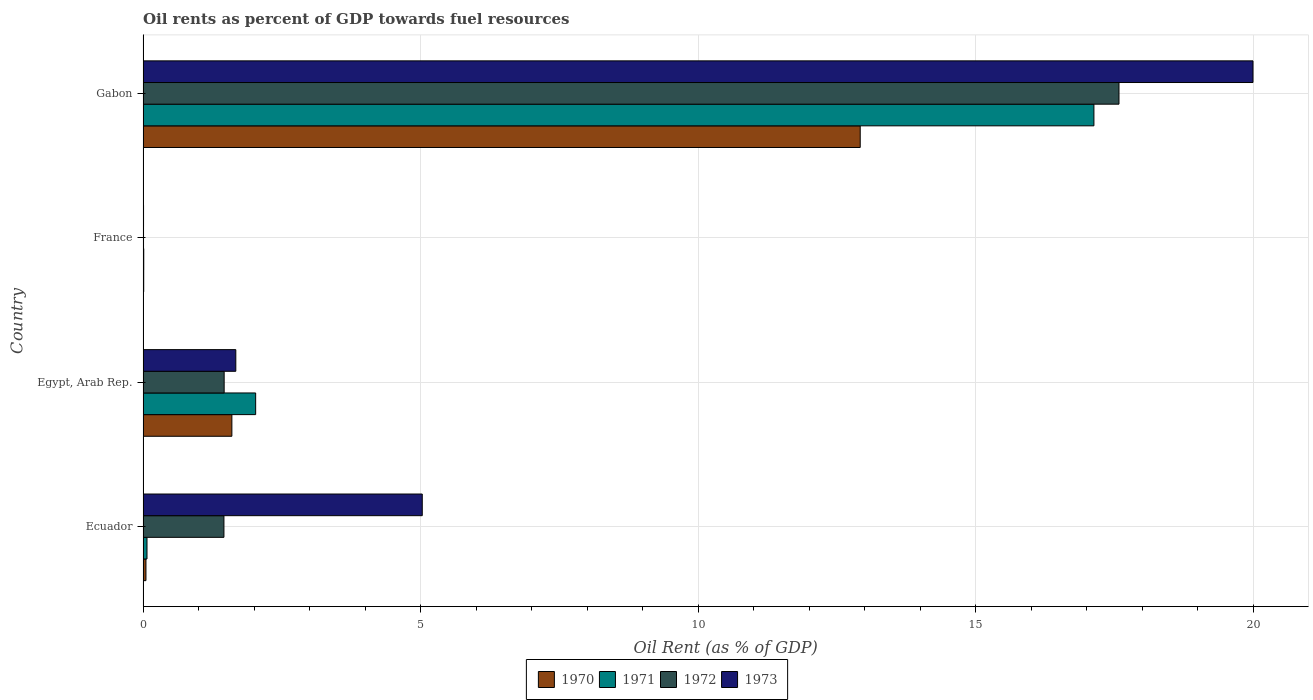How many different coloured bars are there?
Offer a terse response. 4. Are the number of bars per tick equal to the number of legend labels?
Offer a very short reply. Yes. Are the number of bars on each tick of the Y-axis equal?
Your response must be concise. Yes. How many bars are there on the 4th tick from the bottom?
Offer a very short reply. 4. What is the label of the 3rd group of bars from the top?
Keep it short and to the point. Egypt, Arab Rep. In how many cases, is the number of bars for a given country not equal to the number of legend labels?
Give a very brief answer. 0. What is the oil rent in 1973 in Ecuador?
Provide a short and direct response. 5.03. Across all countries, what is the maximum oil rent in 1971?
Offer a terse response. 17.13. Across all countries, what is the minimum oil rent in 1972?
Offer a very short reply. 0.01. In which country was the oil rent in 1973 maximum?
Offer a very short reply. Gabon. What is the total oil rent in 1973 in the graph?
Ensure brevity in your answer.  26.7. What is the difference between the oil rent in 1972 in Egypt, Arab Rep. and that in Gabon?
Provide a succinct answer. -16.12. What is the difference between the oil rent in 1971 in Egypt, Arab Rep. and the oil rent in 1972 in Gabon?
Offer a very short reply. -15.55. What is the average oil rent in 1970 per country?
Make the answer very short. 3.65. What is the difference between the oil rent in 1971 and oil rent in 1972 in Gabon?
Ensure brevity in your answer.  -0.45. What is the ratio of the oil rent in 1972 in France to that in Gabon?
Offer a very short reply. 0. Is the oil rent in 1972 in France less than that in Gabon?
Ensure brevity in your answer.  Yes. Is the difference between the oil rent in 1971 in Ecuador and Gabon greater than the difference between the oil rent in 1972 in Ecuador and Gabon?
Your answer should be very brief. No. What is the difference between the highest and the second highest oil rent in 1972?
Your response must be concise. 16.12. What is the difference between the highest and the lowest oil rent in 1970?
Make the answer very short. 12.91. In how many countries, is the oil rent in 1970 greater than the average oil rent in 1970 taken over all countries?
Offer a terse response. 1. Is the sum of the oil rent in 1971 in Ecuador and Egypt, Arab Rep. greater than the maximum oil rent in 1972 across all countries?
Provide a short and direct response. No. What does the 3rd bar from the bottom in Egypt, Arab Rep. represents?
Keep it short and to the point. 1972. Does the graph contain any zero values?
Give a very brief answer. No. What is the title of the graph?
Provide a succinct answer. Oil rents as percent of GDP towards fuel resources. What is the label or title of the X-axis?
Offer a terse response. Oil Rent (as % of GDP). What is the label or title of the Y-axis?
Keep it short and to the point. Country. What is the Oil Rent (as % of GDP) of 1970 in Ecuador?
Give a very brief answer. 0.05. What is the Oil Rent (as % of GDP) in 1971 in Ecuador?
Offer a very short reply. 0.07. What is the Oil Rent (as % of GDP) of 1972 in Ecuador?
Your answer should be compact. 1.46. What is the Oil Rent (as % of GDP) of 1973 in Ecuador?
Your answer should be very brief. 5.03. What is the Oil Rent (as % of GDP) in 1970 in Egypt, Arab Rep.?
Make the answer very short. 1.6. What is the Oil Rent (as % of GDP) of 1971 in Egypt, Arab Rep.?
Keep it short and to the point. 2.03. What is the Oil Rent (as % of GDP) in 1972 in Egypt, Arab Rep.?
Give a very brief answer. 1.46. What is the Oil Rent (as % of GDP) in 1973 in Egypt, Arab Rep.?
Give a very brief answer. 1.67. What is the Oil Rent (as % of GDP) in 1970 in France?
Keep it short and to the point. 0.01. What is the Oil Rent (as % of GDP) in 1971 in France?
Make the answer very short. 0.01. What is the Oil Rent (as % of GDP) of 1972 in France?
Offer a very short reply. 0.01. What is the Oil Rent (as % of GDP) in 1973 in France?
Your answer should be compact. 0.01. What is the Oil Rent (as % of GDP) in 1970 in Gabon?
Ensure brevity in your answer.  12.92. What is the Oil Rent (as % of GDP) of 1971 in Gabon?
Offer a terse response. 17.13. What is the Oil Rent (as % of GDP) of 1972 in Gabon?
Provide a succinct answer. 17.58. What is the Oil Rent (as % of GDP) in 1973 in Gabon?
Offer a very short reply. 19.99. Across all countries, what is the maximum Oil Rent (as % of GDP) of 1970?
Provide a short and direct response. 12.92. Across all countries, what is the maximum Oil Rent (as % of GDP) of 1971?
Give a very brief answer. 17.13. Across all countries, what is the maximum Oil Rent (as % of GDP) of 1972?
Your answer should be compact. 17.58. Across all countries, what is the maximum Oil Rent (as % of GDP) of 1973?
Ensure brevity in your answer.  19.99. Across all countries, what is the minimum Oil Rent (as % of GDP) in 1970?
Your answer should be compact. 0.01. Across all countries, what is the minimum Oil Rent (as % of GDP) in 1971?
Give a very brief answer. 0.01. Across all countries, what is the minimum Oil Rent (as % of GDP) of 1972?
Provide a short and direct response. 0.01. Across all countries, what is the minimum Oil Rent (as % of GDP) of 1973?
Keep it short and to the point. 0.01. What is the total Oil Rent (as % of GDP) of 1970 in the graph?
Make the answer very short. 14.58. What is the total Oil Rent (as % of GDP) of 1971 in the graph?
Your answer should be very brief. 19.24. What is the total Oil Rent (as % of GDP) in 1972 in the graph?
Your answer should be very brief. 20.51. What is the total Oil Rent (as % of GDP) of 1973 in the graph?
Make the answer very short. 26.7. What is the difference between the Oil Rent (as % of GDP) in 1970 in Ecuador and that in Egypt, Arab Rep.?
Your answer should be compact. -1.55. What is the difference between the Oil Rent (as % of GDP) of 1971 in Ecuador and that in Egypt, Arab Rep.?
Keep it short and to the point. -1.96. What is the difference between the Oil Rent (as % of GDP) of 1972 in Ecuador and that in Egypt, Arab Rep.?
Keep it short and to the point. -0. What is the difference between the Oil Rent (as % of GDP) in 1973 in Ecuador and that in Egypt, Arab Rep.?
Ensure brevity in your answer.  3.36. What is the difference between the Oil Rent (as % of GDP) of 1970 in Ecuador and that in France?
Provide a succinct answer. 0.04. What is the difference between the Oil Rent (as % of GDP) in 1971 in Ecuador and that in France?
Provide a succinct answer. 0.06. What is the difference between the Oil Rent (as % of GDP) in 1972 in Ecuador and that in France?
Provide a short and direct response. 1.45. What is the difference between the Oil Rent (as % of GDP) in 1973 in Ecuador and that in France?
Make the answer very short. 5.02. What is the difference between the Oil Rent (as % of GDP) of 1970 in Ecuador and that in Gabon?
Your answer should be compact. -12.87. What is the difference between the Oil Rent (as % of GDP) of 1971 in Ecuador and that in Gabon?
Provide a succinct answer. -17.06. What is the difference between the Oil Rent (as % of GDP) in 1972 in Ecuador and that in Gabon?
Offer a terse response. -16.12. What is the difference between the Oil Rent (as % of GDP) in 1973 in Ecuador and that in Gabon?
Ensure brevity in your answer.  -14.96. What is the difference between the Oil Rent (as % of GDP) in 1970 in Egypt, Arab Rep. and that in France?
Your response must be concise. 1.59. What is the difference between the Oil Rent (as % of GDP) of 1971 in Egypt, Arab Rep. and that in France?
Offer a terse response. 2.02. What is the difference between the Oil Rent (as % of GDP) of 1972 in Egypt, Arab Rep. and that in France?
Give a very brief answer. 1.45. What is the difference between the Oil Rent (as % of GDP) in 1973 in Egypt, Arab Rep. and that in France?
Your answer should be very brief. 1.66. What is the difference between the Oil Rent (as % of GDP) of 1970 in Egypt, Arab Rep. and that in Gabon?
Ensure brevity in your answer.  -11.32. What is the difference between the Oil Rent (as % of GDP) in 1971 in Egypt, Arab Rep. and that in Gabon?
Give a very brief answer. -15.1. What is the difference between the Oil Rent (as % of GDP) of 1972 in Egypt, Arab Rep. and that in Gabon?
Your answer should be compact. -16.12. What is the difference between the Oil Rent (as % of GDP) of 1973 in Egypt, Arab Rep. and that in Gabon?
Make the answer very short. -18.32. What is the difference between the Oil Rent (as % of GDP) in 1970 in France and that in Gabon?
Keep it short and to the point. -12.91. What is the difference between the Oil Rent (as % of GDP) in 1971 in France and that in Gabon?
Offer a very short reply. -17.12. What is the difference between the Oil Rent (as % of GDP) in 1972 in France and that in Gabon?
Ensure brevity in your answer.  -17.57. What is the difference between the Oil Rent (as % of GDP) of 1973 in France and that in Gabon?
Your answer should be very brief. -19.98. What is the difference between the Oil Rent (as % of GDP) in 1970 in Ecuador and the Oil Rent (as % of GDP) in 1971 in Egypt, Arab Rep.?
Your response must be concise. -1.98. What is the difference between the Oil Rent (as % of GDP) of 1970 in Ecuador and the Oil Rent (as % of GDP) of 1972 in Egypt, Arab Rep.?
Your response must be concise. -1.41. What is the difference between the Oil Rent (as % of GDP) in 1970 in Ecuador and the Oil Rent (as % of GDP) in 1973 in Egypt, Arab Rep.?
Your response must be concise. -1.62. What is the difference between the Oil Rent (as % of GDP) in 1971 in Ecuador and the Oil Rent (as % of GDP) in 1972 in Egypt, Arab Rep.?
Offer a very short reply. -1.39. What is the difference between the Oil Rent (as % of GDP) in 1971 in Ecuador and the Oil Rent (as % of GDP) in 1973 in Egypt, Arab Rep.?
Your answer should be very brief. -1.6. What is the difference between the Oil Rent (as % of GDP) in 1972 in Ecuador and the Oil Rent (as % of GDP) in 1973 in Egypt, Arab Rep.?
Offer a terse response. -0.21. What is the difference between the Oil Rent (as % of GDP) of 1970 in Ecuador and the Oil Rent (as % of GDP) of 1971 in France?
Ensure brevity in your answer.  0.04. What is the difference between the Oil Rent (as % of GDP) in 1970 in Ecuador and the Oil Rent (as % of GDP) in 1972 in France?
Ensure brevity in your answer.  0.04. What is the difference between the Oil Rent (as % of GDP) in 1970 in Ecuador and the Oil Rent (as % of GDP) in 1973 in France?
Provide a succinct answer. 0.04. What is the difference between the Oil Rent (as % of GDP) in 1971 in Ecuador and the Oil Rent (as % of GDP) in 1972 in France?
Give a very brief answer. 0.06. What is the difference between the Oil Rent (as % of GDP) in 1971 in Ecuador and the Oil Rent (as % of GDP) in 1973 in France?
Provide a succinct answer. 0.06. What is the difference between the Oil Rent (as % of GDP) of 1972 in Ecuador and the Oil Rent (as % of GDP) of 1973 in France?
Offer a terse response. 1.45. What is the difference between the Oil Rent (as % of GDP) in 1970 in Ecuador and the Oil Rent (as % of GDP) in 1971 in Gabon?
Provide a short and direct response. -17.08. What is the difference between the Oil Rent (as % of GDP) in 1970 in Ecuador and the Oil Rent (as % of GDP) in 1972 in Gabon?
Offer a very short reply. -17.53. What is the difference between the Oil Rent (as % of GDP) in 1970 in Ecuador and the Oil Rent (as % of GDP) in 1973 in Gabon?
Provide a succinct answer. -19.94. What is the difference between the Oil Rent (as % of GDP) of 1971 in Ecuador and the Oil Rent (as % of GDP) of 1972 in Gabon?
Your response must be concise. -17.51. What is the difference between the Oil Rent (as % of GDP) of 1971 in Ecuador and the Oil Rent (as % of GDP) of 1973 in Gabon?
Make the answer very short. -19.92. What is the difference between the Oil Rent (as % of GDP) of 1972 in Ecuador and the Oil Rent (as % of GDP) of 1973 in Gabon?
Provide a short and direct response. -18.54. What is the difference between the Oil Rent (as % of GDP) in 1970 in Egypt, Arab Rep. and the Oil Rent (as % of GDP) in 1971 in France?
Keep it short and to the point. 1.59. What is the difference between the Oil Rent (as % of GDP) in 1970 in Egypt, Arab Rep. and the Oil Rent (as % of GDP) in 1972 in France?
Ensure brevity in your answer.  1.59. What is the difference between the Oil Rent (as % of GDP) in 1970 in Egypt, Arab Rep. and the Oil Rent (as % of GDP) in 1973 in France?
Ensure brevity in your answer.  1.59. What is the difference between the Oil Rent (as % of GDP) of 1971 in Egypt, Arab Rep. and the Oil Rent (as % of GDP) of 1972 in France?
Your answer should be very brief. 2.02. What is the difference between the Oil Rent (as % of GDP) of 1971 in Egypt, Arab Rep. and the Oil Rent (as % of GDP) of 1973 in France?
Give a very brief answer. 2.02. What is the difference between the Oil Rent (as % of GDP) in 1972 in Egypt, Arab Rep. and the Oil Rent (as % of GDP) in 1973 in France?
Your answer should be very brief. 1.45. What is the difference between the Oil Rent (as % of GDP) of 1970 in Egypt, Arab Rep. and the Oil Rent (as % of GDP) of 1971 in Gabon?
Your response must be concise. -15.53. What is the difference between the Oil Rent (as % of GDP) of 1970 in Egypt, Arab Rep. and the Oil Rent (as % of GDP) of 1972 in Gabon?
Ensure brevity in your answer.  -15.98. What is the difference between the Oil Rent (as % of GDP) in 1970 in Egypt, Arab Rep. and the Oil Rent (as % of GDP) in 1973 in Gabon?
Offer a terse response. -18.39. What is the difference between the Oil Rent (as % of GDP) in 1971 in Egypt, Arab Rep. and the Oil Rent (as % of GDP) in 1972 in Gabon?
Offer a very short reply. -15.55. What is the difference between the Oil Rent (as % of GDP) in 1971 in Egypt, Arab Rep. and the Oil Rent (as % of GDP) in 1973 in Gabon?
Provide a succinct answer. -17.97. What is the difference between the Oil Rent (as % of GDP) of 1972 in Egypt, Arab Rep. and the Oil Rent (as % of GDP) of 1973 in Gabon?
Offer a terse response. -18.53. What is the difference between the Oil Rent (as % of GDP) of 1970 in France and the Oil Rent (as % of GDP) of 1971 in Gabon?
Keep it short and to the point. -17.12. What is the difference between the Oil Rent (as % of GDP) of 1970 in France and the Oil Rent (as % of GDP) of 1972 in Gabon?
Offer a very short reply. -17.57. What is the difference between the Oil Rent (as % of GDP) of 1970 in France and the Oil Rent (as % of GDP) of 1973 in Gabon?
Your answer should be compact. -19.98. What is the difference between the Oil Rent (as % of GDP) in 1971 in France and the Oil Rent (as % of GDP) in 1972 in Gabon?
Your answer should be compact. -17.57. What is the difference between the Oil Rent (as % of GDP) in 1971 in France and the Oil Rent (as % of GDP) in 1973 in Gabon?
Keep it short and to the point. -19.98. What is the difference between the Oil Rent (as % of GDP) of 1972 in France and the Oil Rent (as % of GDP) of 1973 in Gabon?
Keep it short and to the point. -19.99. What is the average Oil Rent (as % of GDP) in 1970 per country?
Your answer should be compact. 3.65. What is the average Oil Rent (as % of GDP) in 1971 per country?
Make the answer very short. 4.81. What is the average Oil Rent (as % of GDP) in 1972 per country?
Offer a terse response. 5.13. What is the average Oil Rent (as % of GDP) in 1973 per country?
Ensure brevity in your answer.  6.68. What is the difference between the Oil Rent (as % of GDP) of 1970 and Oil Rent (as % of GDP) of 1971 in Ecuador?
Ensure brevity in your answer.  -0.02. What is the difference between the Oil Rent (as % of GDP) of 1970 and Oil Rent (as % of GDP) of 1972 in Ecuador?
Offer a terse response. -1.41. What is the difference between the Oil Rent (as % of GDP) of 1970 and Oil Rent (as % of GDP) of 1973 in Ecuador?
Offer a terse response. -4.98. What is the difference between the Oil Rent (as % of GDP) of 1971 and Oil Rent (as % of GDP) of 1972 in Ecuador?
Keep it short and to the point. -1.39. What is the difference between the Oil Rent (as % of GDP) of 1971 and Oil Rent (as % of GDP) of 1973 in Ecuador?
Your response must be concise. -4.96. What is the difference between the Oil Rent (as % of GDP) in 1972 and Oil Rent (as % of GDP) in 1973 in Ecuador?
Your answer should be compact. -3.57. What is the difference between the Oil Rent (as % of GDP) in 1970 and Oil Rent (as % of GDP) in 1971 in Egypt, Arab Rep.?
Provide a succinct answer. -0.43. What is the difference between the Oil Rent (as % of GDP) of 1970 and Oil Rent (as % of GDP) of 1972 in Egypt, Arab Rep.?
Your response must be concise. 0.14. What is the difference between the Oil Rent (as % of GDP) in 1970 and Oil Rent (as % of GDP) in 1973 in Egypt, Arab Rep.?
Your answer should be very brief. -0.07. What is the difference between the Oil Rent (as % of GDP) of 1971 and Oil Rent (as % of GDP) of 1972 in Egypt, Arab Rep.?
Make the answer very short. 0.57. What is the difference between the Oil Rent (as % of GDP) in 1971 and Oil Rent (as % of GDP) in 1973 in Egypt, Arab Rep.?
Offer a terse response. 0.36. What is the difference between the Oil Rent (as % of GDP) of 1972 and Oil Rent (as % of GDP) of 1973 in Egypt, Arab Rep.?
Keep it short and to the point. -0.21. What is the difference between the Oil Rent (as % of GDP) in 1970 and Oil Rent (as % of GDP) in 1971 in France?
Your answer should be compact. -0. What is the difference between the Oil Rent (as % of GDP) of 1970 and Oil Rent (as % of GDP) of 1972 in France?
Your response must be concise. 0. What is the difference between the Oil Rent (as % of GDP) in 1970 and Oil Rent (as % of GDP) in 1973 in France?
Provide a succinct answer. 0. What is the difference between the Oil Rent (as % of GDP) of 1971 and Oil Rent (as % of GDP) of 1972 in France?
Keep it short and to the point. 0. What is the difference between the Oil Rent (as % of GDP) in 1971 and Oil Rent (as % of GDP) in 1973 in France?
Make the answer very short. 0. What is the difference between the Oil Rent (as % of GDP) of 1972 and Oil Rent (as % of GDP) of 1973 in France?
Keep it short and to the point. -0. What is the difference between the Oil Rent (as % of GDP) in 1970 and Oil Rent (as % of GDP) in 1971 in Gabon?
Make the answer very short. -4.21. What is the difference between the Oil Rent (as % of GDP) in 1970 and Oil Rent (as % of GDP) in 1972 in Gabon?
Your answer should be compact. -4.66. What is the difference between the Oil Rent (as % of GDP) of 1970 and Oil Rent (as % of GDP) of 1973 in Gabon?
Provide a succinct answer. -7.08. What is the difference between the Oil Rent (as % of GDP) of 1971 and Oil Rent (as % of GDP) of 1972 in Gabon?
Keep it short and to the point. -0.45. What is the difference between the Oil Rent (as % of GDP) in 1971 and Oil Rent (as % of GDP) in 1973 in Gabon?
Keep it short and to the point. -2.87. What is the difference between the Oil Rent (as % of GDP) of 1972 and Oil Rent (as % of GDP) of 1973 in Gabon?
Ensure brevity in your answer.  -2.41. What is the ratio of the Oil Rent (as % of GDP) of 1970 in Ecuador to that in Egypt, Arab Rep.?
Provide a succinct answer. 0.03. What is the ratio of the Oil Rent (as % of GDP) of 1971 in Ecuador to that in Egypt, Arab Rep.?
Your answer should be compact. 0.03. What is the ratio of the Oil Rent (as % of GDP) in 1973 in Ecuador to that in Egypt, Arab Rep.?
Provide a succinct answer. 3.01. What is the ratio of the Oil Rent (as % of GDP) of 1970 in Ecuador to that in France?
Offer a terse response. 4.52. What is the ratio of the Oil Rent (as % of GDP) in 1971 in Ecuador to that in France?
Offer a terse response. 5.74. What is the ratio of the Oil Rent (as % of GDP) in 1972 in Ecuador to that in France?
Ensure brevity in your answer.  171.48. What is the ratio of the Oil Rent (as % of GDP) in 1973 in Ecuador to that in France?
Offer a very short reply. 569.07. What is the ratio of the Oil Rent (as % of GDP) in 1970 in Ecuador to that in Gabon?
Your response must be concise. 0. What is the ratio of the Oil Rent (as % of GDP) in 1971 in Ecuador to that in Gabon?
Your response must be concise. 0. What is the ratio of the Oil Rent (as % of GDP) in 1972 in Ecuador to that in Gabon?
Keep it short and to the point. 0.08. What is the ratio of the Oil Rent (as % of GDP) of 1973 in Ecuador to that in Gabon?
Provide a succinct answer. 0.25. What is the ratio of the Oil Rent (as % of GDP) in 1970 in Egypt, Arab Rep. to that in France?
Provide a succinct answer. 139.1. What is the ratio of the Oil Rent (as % of GDP) in 1971 in Egypt, Arab Rep. to that in France?
Provide a succinct answer. 164.4. What is the ratio of the Oil Rent (as % of GDP) in 1972 in Egypt, Arab Rep. to that in France?
Give a very brief answer. 171.93. What is the ratio of the Oil Rent (as % of GDP) of 1973 in Egypt, Arab Rep. to that in France?
Ensure brevity in your answer.  189.03. What is the ratio of the Oil Rent (as % of GDP) in 1970 in Egypt, Arab Rep. to that in Gabon?
Provide a succinct answer. 0.12. What is the ratio of the Oil Rent (as % of GDP) of 1971 in Egypt, Arab Rep. to that in Gabon?
Ensure brevity in your answer.  0.12. What is the ratio of the Oil Rent (as % of GDP) of 1972 in Egypt, Arab Rep. to that in Gabon?
Offer a very short reply. 0.08. What is the ratio of the Oil Rent (as % of GDP) in 1973 in Egypt, Arab Rep. to that in Gabon?
Offer a terse response. 0.08. What is the ratio of the Oil Rent (as % of GDP) of 1970 in France to that in Gabon?
Ensure brevity in your answer.  0. What is the ratio of the Oil Rent (as % of GDP) in 1971 in France to that in Gabon?
Give a very brief answer. 0. What is the difference between the highest and the second highest Oil Rent (as % of GDP) in 1970?
Ensure brevity in your answer.  11.32. What is the difference between the highest and the second highest Oil Rent (as % of GDP) of 1971?
Ensure brevity in your answer.  15.1. What is the difference between the highest and the second highest Oil Rent (as % of GDP) in 1972?
Offer a terse response. 16.12. What is the difference between the highest and the second highest Oil Rent (as % of GDP) in 1973?
Provide a short and direct response. 14.96. What is the difference between the highest and the lowest Oil Rent (as % of GDP) in 1970?
Offer a terse response. 12.91. What is the difference between the highest and the lowest Oil Rent (as % of GDP) in 1971?
Your answer should be very brief. 17.12. What is the difference between the highest and the lowest Oil Rent (as % of GDP) in 1972?
Give a very brief answer. 17.57. What is the difference between the highest and the lowest Oil Rent (as % of GDP) of 1973?
Keep it short and to the point. 19.98. 